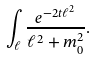<formula> <loc_0><loc_0><loc_500><loc_500>\int _ { \ell } \frac { e ^ { - 2 t \ell ^ { 2 } } } { \ell ^ { 2 } + m _ { 0 } ^ { 2 } } .</formula> 